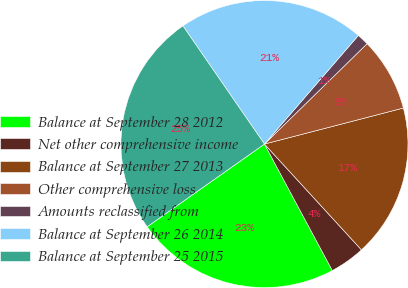<chart> <loc_0><loc_0><loc_500><loc_500><pie_chart><fcel>Balance at September 28 2012<fcel>Net other comprehensive income<fcel>Balance at September 27 2013<fcel>Other comprehensive loss<fcel>Amounts reclassified from<fcel>Balance at September 26 2014<fcel>Balance at September 25 2015<nl><fcel>23.06%<fcel>3.97%<fcel>17.23%<fcel>8.28%<fcel>1.33%<fcel>20.96%<fcel>25.16%<nl></chart> 